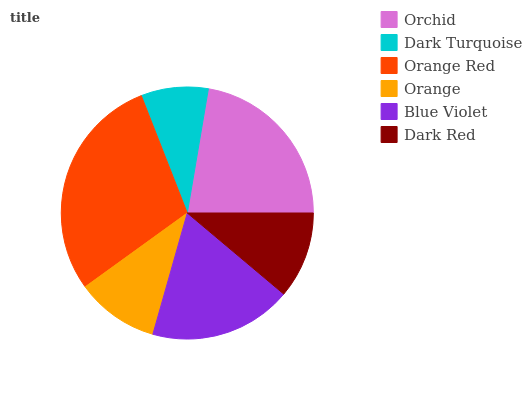Is Dark Turquoise the minimum?
Answer yes or no. Yes. Is Orange Red the maximum?
Answer yes or no. Yes. Is Orange Red the minimum?
Answer yes or no. No. Is Dark Turquoise the maximum?
Answer yes or no. No. Is Orange Red greater than Dark Turquoise?
Answer yes or no. Yes. Is Dark Turquoise less than Orange Red?
Answer yes or no. Yes. Is Dark Turquoise greater than Orange Red?
Answer yes or no. No. Is Orange Red less than Dark Turquoise?
Answer yes or no. No. Is Blue Violet the high median?
Answer yes or no. Yes. Is Dark Red the low median?
Answer yes or no. Yes. Is Dark Red the high median?
Answer yes or no. No. Is Orchid the low median?
Answer yes or no. No. 